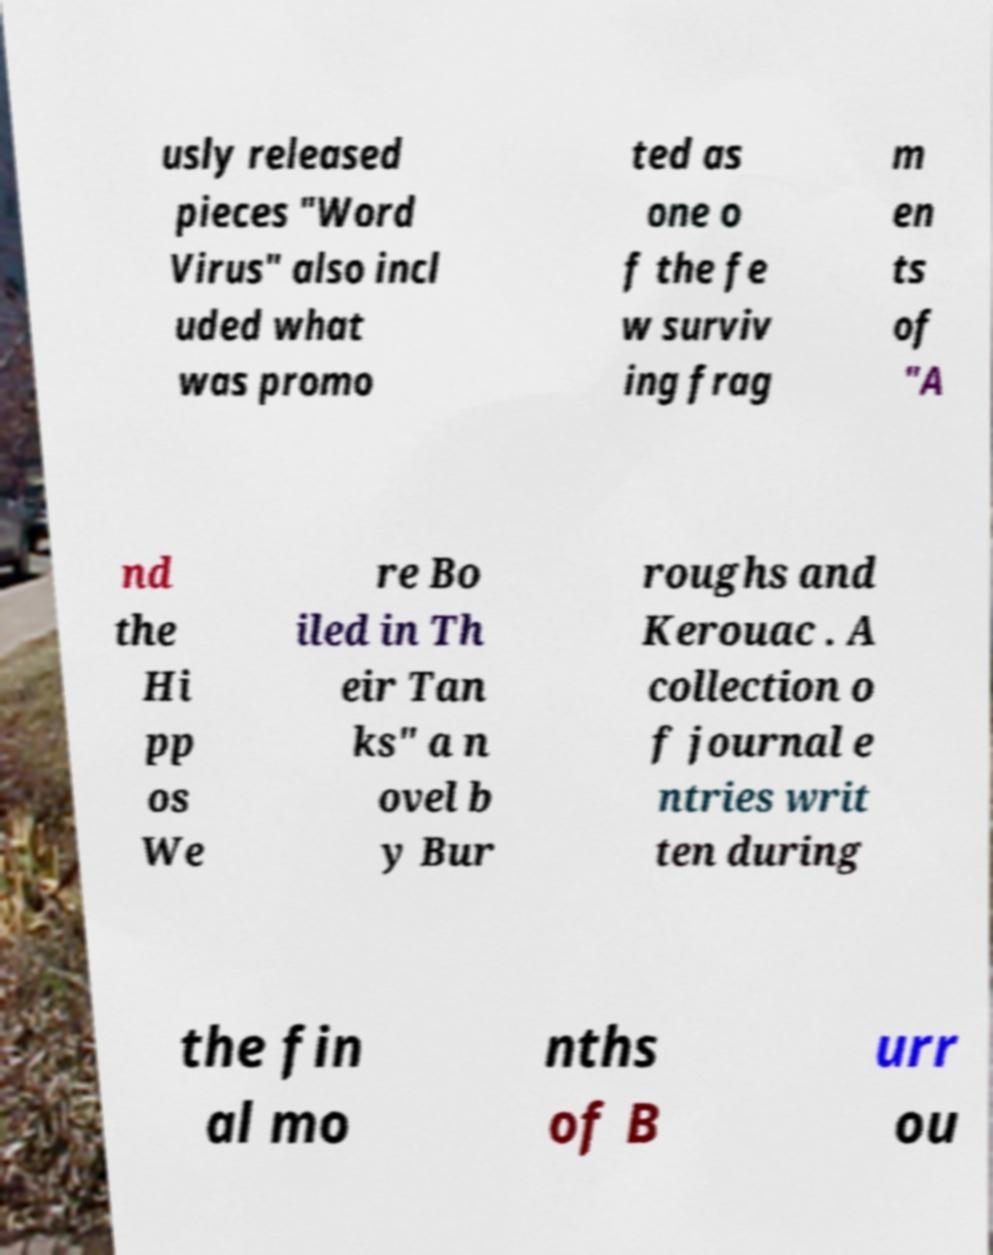There's text embedded in this image that I need extracted. Can you transcribe it verbatim? usly released pieces "Word Virus" also incl uded what was promo ted as one o f the fe w surviv ing frag m en ts of "A nd the Hi pp os We re Bo iled in Th eir Tan ks" a n ovel b y Bur roughs and Kerouac . A collection o f journal e ntries writ ten during the fin al mo nths of B urr ou 